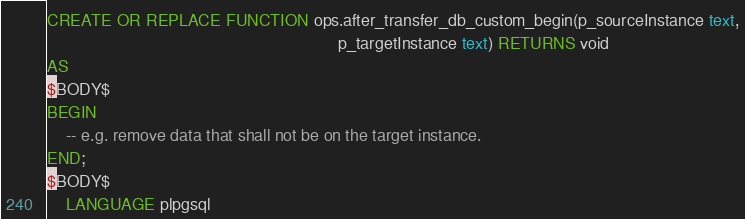Convert code to text. <code><loc_0><loc_0><loc_500><loc_500><_SQL_>CREATE OR REPLACE FUNCTION ops.after_transfer_db_custom_begin(p_sourceInstance text,
                                                              p_targetInstance text) RETURNS void
AS
$BODY$
BEGIN
    -- e.g. remove data that shall not be on the target instance.
END;
$BODY$
    LANGUAGE plpgsql</code> 